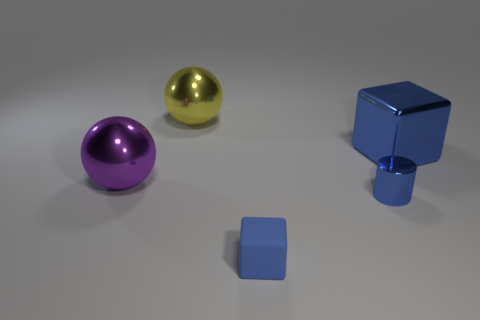Add 2 gray rubber cubes. How many objects exist? 7 Subtract all purple spheres. How many spheres are left? 1 Add 5 large blocks. How many large blocks are left? 6 Add 5 large red matte blocks. How many large red matte blocks exist? 5 Subtract 0 brown blocks. How many objects are left? 5 Subtract all blocks. How many objects are left? 3 Subtract 1 blocks. How many blocks are left? 1 Subtract all brown cubes. Subtract all red cylinders. How many cubes are left? 2 Subtract all purple cylinders. How many yellow spheres are left? 1 Subtract all tiny red rubber objects. Subtract all blue blocks. How many objects are left? 3 